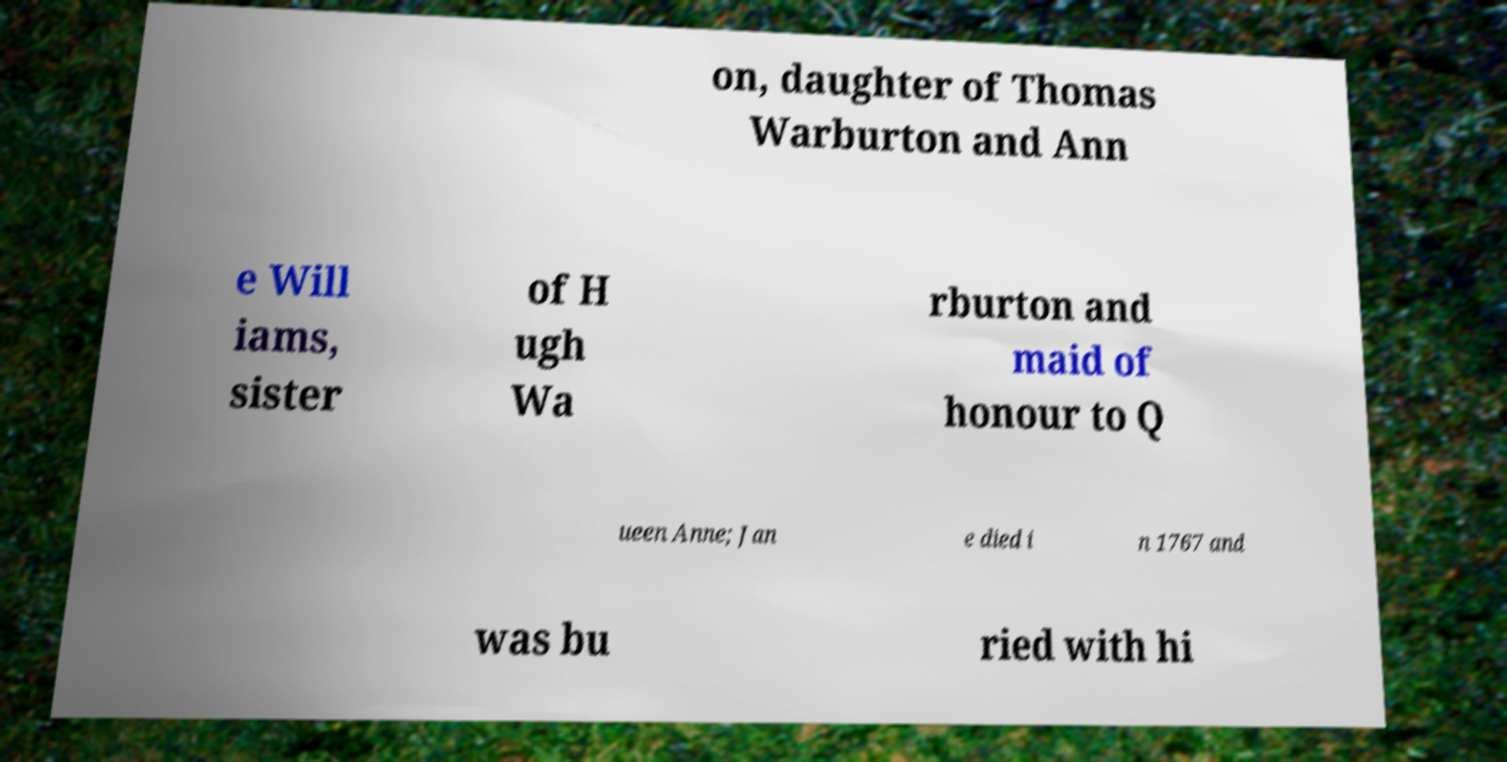What messages or text are displayed in this image? I need them in a readable, typed format. on, daughter of Thomas Warburton and Ann e Will iams, sister of H ugh Wa rburton and maid of honour to Q ueen Anne; Jan e died i n 1767 and was bu ried with hi 